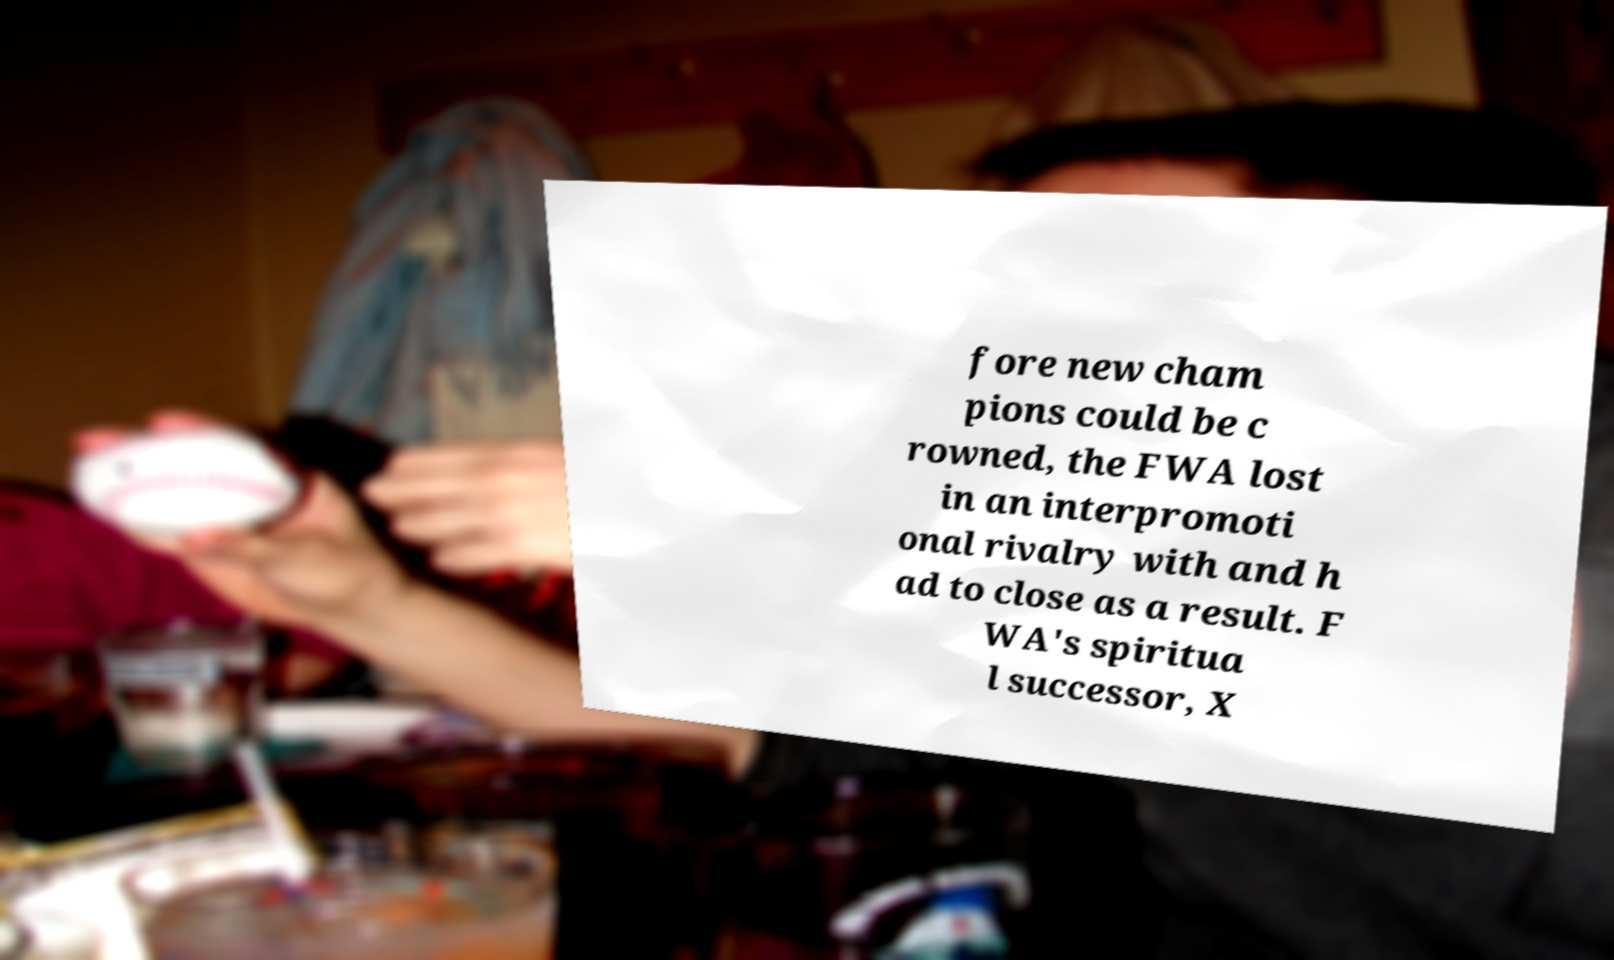Please read and relay the text visible in this image. What does it say? fore new cham pions could be c rowned, the FWA lost in an interpromoti onal rivalry with and h ad to close as a result. F WA's spiritua l successor, X 